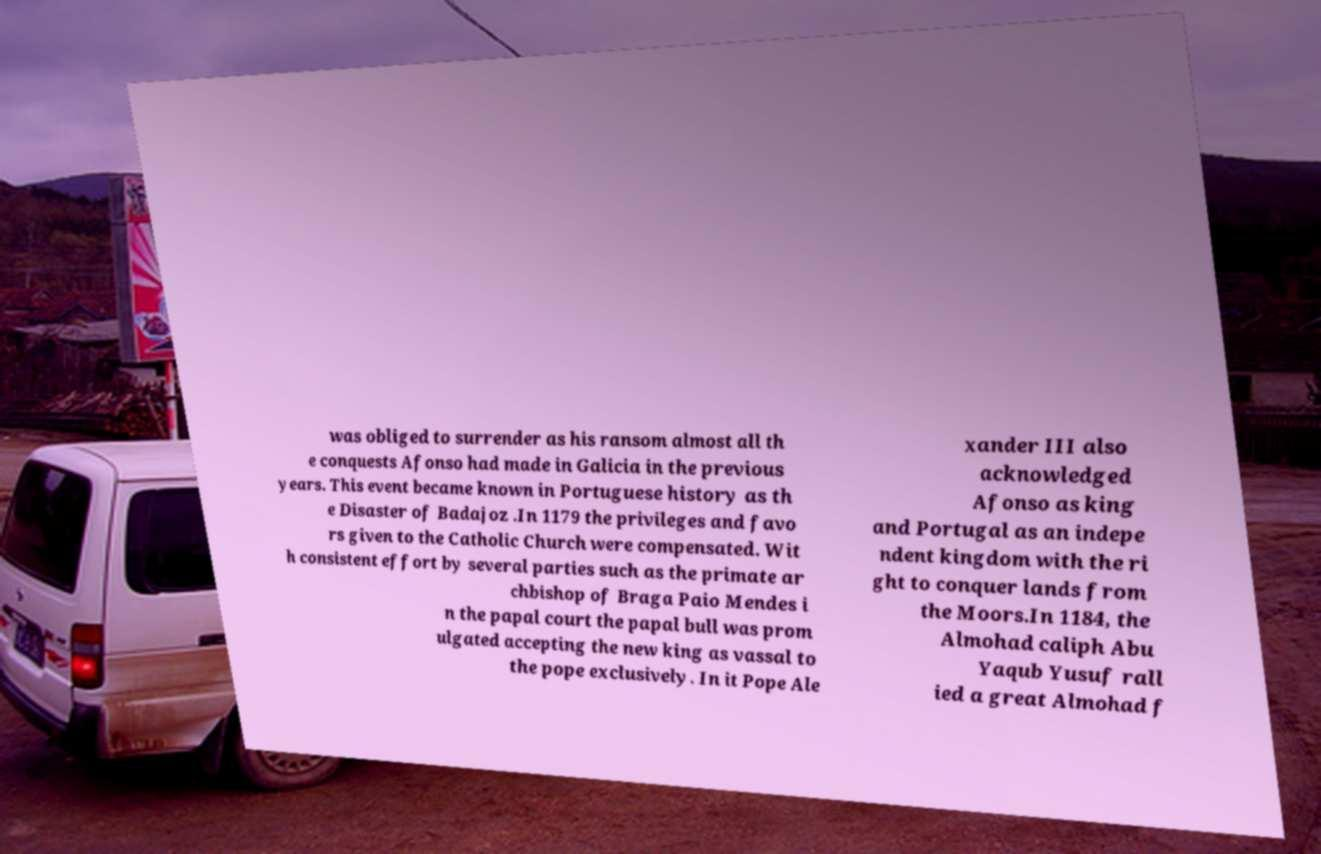Could you assist in decoding the text presented in this image and type it out clearly? was obliged to surrender as his ransom almost all th e conquests Afonso had made in Galicia in the previous years. This event became known in Portuguese history as th e Disaster of Badajoz .In 1179 the privileges and favo rs given to the Catholic Church were compensated. Wit h consistent effort by several parties such as the primate ar chbishop of Braga Paio Mendes i n the papal court the papal bull was prom ulgated accepting the new king as vassal to the pope exclusively. In it Pope Ale xander III also acknowledged Afonso as king and Portugal as an indepe ndent kingdom with the ri ght to conquer lands from the Moors.In 1184, the Almohad caliph Abu Yaqub Yusuf rall ied a great Almohad f 